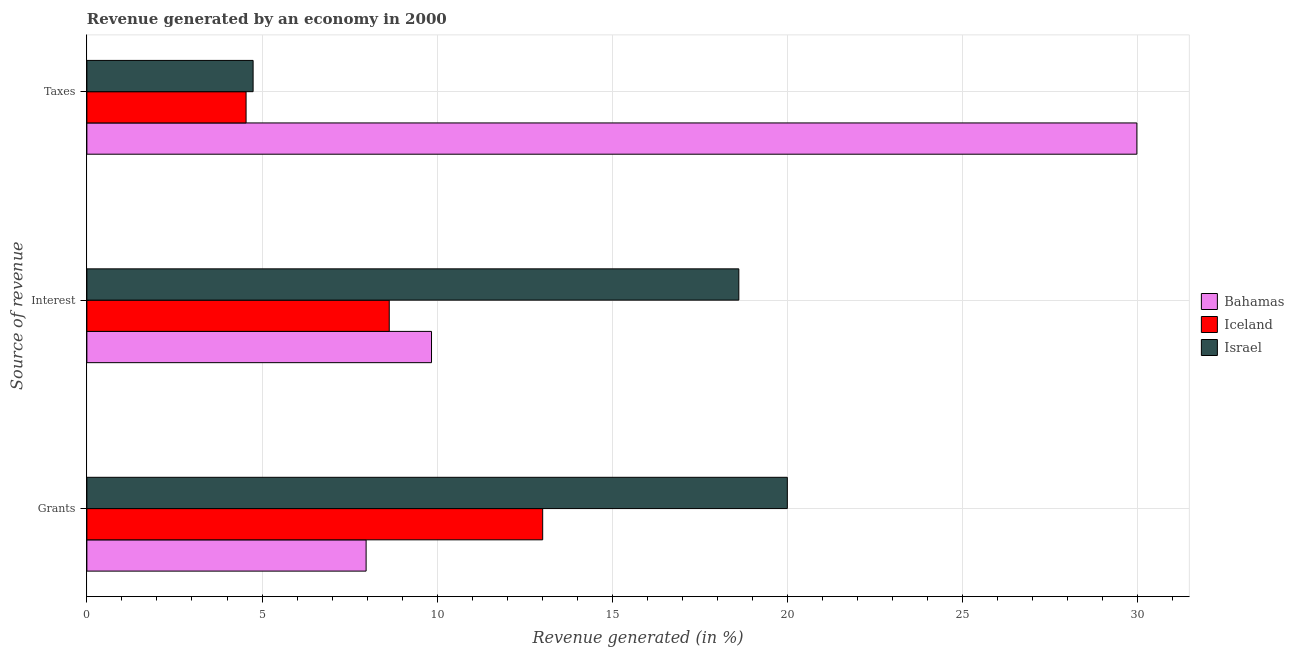How many different coloured bars are there?
Give a very brief answer. 3. How many groups of bars are there?
Make the answer very short. 3. Are the number of bars per tick equal to the number of legend labels?
Your response must be concise. Yes. Are the number of bars on each tick of the Y-axis equal?
Keep it short and to the point. Yes. What is the label of the 2nd group of bars from the top?
Keep it short and to the point. Interest. What is the percentage of revenue generated by interest in Bahamas?
Your answer should be compact. 9.84. Across all countries, what is the maximum percentage of revenue generated by grants?
Keep it short and to the point. 20. Across all countries, what is the minimum percentage of revenue generated by grants?
Give a very brief answer. 7.97. In which country was the percentage of revenue generated by grants minimum?
Make the answer very short. Bahamas. What is the total percentage of revenue generated by interest in the graph?
Offer a terse response. 37.08. What is the difference between the percentage of revenue generated by grants in Bahamas and that in Iceland?
Your answer should be compact. -5.04. What is the difference between the percentage of revenue generated by grants in Bahamas and the percentage of revenue generated by taxes in Israel?
Your response must be concise. 3.23. What is the average percentage of revenue generated by taxes per country?
Keep it short and to the point. 13.09. What is the difference between the percentage of revenue generated by grants and percentage of revenue generated by interest in Bahamas?
Your answer should be very brief. -1.87. What is the ratio of the percentage of revenue generated by interest in Israel to that in Bahamas?
Your answer should be very brief. 1.89. What is the difference between the highest and the second highest percentage of revenue generated by grants?
Make the answer very short. 6.98. What is the difference between the highest and the lowest percentage of revenue generated by taxes?
Ensure brevity in your answer.  25.43. In how many countries, is the percentage of revenue generated by grants greater than the average percentage of revenue generated by grants taken over all countries?
Ensure brevity in your answer.  1. What does the 3rd bar from the bottom in Interest represents?
Keep it short and to the point. Israel. Are the values on the major ticks of X-axis written in scientific E-notation?
Ensure brevity in your answer.  No. Does the graph contain grids?
Your answer should be very brief. Yes. Where does the legend appear in the graph?
Your answer should be compact. Center right. How many legend labels are there?
Offer a terse response. 3. What is the title of the graph?
Offer a very short reply. Revenue generated by an economy in 2000. Does "Marshall Islands" appear as one of the legend labels in the graph?
Give a very brief answer. No. What is the label or title of the X-axis?
Provide a short and direct response. Revenue generated (in %). What is the label or title of the Y-axis?
Ensure brevity in your answer.  Source of revenue. What is the Revenue generated (in %) in Bahamas in Grants?
Provide a succinct answer. 7.97. What is the Revenue generated (in %) in Iceland in Grants?
Give a very brief answer. 13.01. What is the Revenue generated (in %) in Israel in Grants?
Make the answer very short. 20. What is the Revenue generated (in %) in Bahamas in Interest?
Make the answer very short. 9.84. What is the Revenue generated (in %) in Iceland in Interest?
Give a very brief answer. 8.63. What is the Revenue generated (in %) in Israel in Interest?
Provide a succinct answer. 18.61. What is the Revenue generated (in %) in Bahamas in Taxes?
Your answer should be very brief. 29.97. What is the Revenue generated (in %) in Iceland in Taxes?
Your response must be concise. 4.54. What is the Revenue generated (in %) of Israel in Taxes?
Offer a terse response. 4.75. Across all Source of revenue, what is the maximum Revenue generated (in %) in Bahamas?
Keep it short and to the point. 29.97. Across all Source of revenue, what is the maximum Revenue generated (in %) of Iceland?
Your response must be concise. 13.01. Across all Source of revenue, what is the maximum Revenue generated (in %) of Israel?
Provide a succinct answer. 20. Across all Source of revenue, what is the minimum Revenue generated (in %) of Bahamas?
Your response must be concise. 7.97. Across all Source of revenue, what is the minimum Revenue generated (in %) in Iceland?
Your answer should be compact. 4.54. Across all Source of revenue, what is the minimum Revenue generated (in %) in Israel?
Give a very brief answer. 4.75. What is the total Revenue generated (in %) of Bahamas in the graph?
Give a very brief answer. 47.78. What is the total Revenue generated (in %) of Iceland in the graph?
Provide a succinct answer. 26.19. What is the total Revenue generated (in %) in Israel in the graph?
Your answer should be very brief. 43.35. What is the difference between the Revenue generated (in %) of Bahamas in Grants and that in Interest?
Provide a succinct answer. -1.87. What is the difference between the Revenue generated (in %) of Iceland in Grants and that in Interest?
Your answer should be very brief. 4.38. What is the difference between the Revenue generated (in %) of Israel in Grants and that in Interest?
Your response must be concise. 1.38. What is the difference between the Revenue generated (in %) in Bahamas in Grants and that in Taxes?
Offer a very short reply. -22. What is the difference between the Revenue generated (in %) of Iceland in Grants and that in Taxes?
Ensure brevity in your answer.  8.47. What is the difference between the Revenue generated (in %) of Israel in Grants and that in Taxes?
Give a very brief answer. 15.25. What is the difference between the Revenue generated (in %) of Bahamas in Interest and that in Taxes?
Offer a very short reply. -20.14. What is the difference between the Revenue generated (in %) in Iceland in Interest and that in Taxes?
Your answer should be compact. 4.09. What is the difference between the Revenue generated (in %) in Israel in Interest and that in Taxes?
Provide a succinct answer. 13.87. What is the difference between the Revenue generated (in %) in Bahamas in Grants and the Revenue generated (in %) in Iceland in Interest?
Offer a very short reply. -0.66. What is the difference between the Revenue generated (in %) of Bahamas in Grants and the Revenue generated (in %) of Israel in Interest?
Your response must be concise. -10.64. What is the difference between the Revenue generated (in %) of Iceland in Grants and the Revenue generated (in %) of Israel in Interest?
Ensure brevity in your answer.  -5.6. What is the difference between the Revenue generated (in %) of Bahamas in Grants and the Revenue generated (in %) of Iceland in Taxes?
Your answer should be compact. 3.43. What is the difference between the Revenue generated (in %) of Bahamas in Grants and the Revenue generated (in %) of Israel in Taxes?
Offer a terse response. 3.23. What is the difference between the Revenue generated (in %) in Iceland in Grants and the Revenue generated (in %) in Israel in Taxes?
Keep it short and to the point. 8.27. What is the difference between the Revenue generated (in %) of Bahamas in Interest and the Revenue generated (in %) of Iceland in Taxes?
Make the answer very short. 5.29. What is the difference between the Revenue generated (in %) of Bahamas in Interest and the Revenue generated (in %) of Israel in Taxes?
Ensure brevity in your answer.  5.09. What is the difference between the Revenue generated (in %) in Iceland in Interest and the Revenue generated (in %) in Israel in Taxes?
Your response must be concise. 3.89. What is the average Revenue generated (in %) of Bahamas per Source of revenue?
Ensure brevity in your answer.  15.93. What is the average Revenue generated (in %) in Iceland per Source of revenue?
Your answer should be compact. 8.73. What is the average Revenue generated (in %) in Israel per Source of revenue?
Ensure brevity in your answer.  14.45. What is the difference between the Revenue generated (in %) in Bahamas and Revenue generated (in %) in Iceland in Grants?
Provide a short and direct response. -5.04. What is the difference between the Revenue generated (in %) of Bahamas and Revenue generated (in %) of Israel in Grants?
Your answer should be compact. -12.02. What is the difference between the Revenue generated (in %) in Iceland and Revenue generated (in %) in Israel in Grants?
Your answer should be compact. -6.98. What is the difference between the Revenue generated (in %) in Bahamas and Revenue generated (in %) in Iceland in Interest?
Give a very brief answer. 1.21. What is the difference between the Revenue generated (in %) in Bahamas and Revenue generated (in %) in Israel in Interest?
Your response must be concise. -8.77. What is the difference between the Revenue generated (in %) in Iceland and Revenue generated (in %) in Israel in Interest?
Give a very brief answer. -9.98. What is the difference between the Revenue generated (in %) in Bahamas and Revenue generated (in %) in Iceland in Taxes?
Give a very brief answer. 25.43. What is the difference between the Revenue generated (in %) of Bahamas and Revenue generated (in %) of Israel in Taxes?
Give a very brief answer. 25.23. What is the difference between the Revenue generated (in %) in Iceland and Revenue generated (in %) in Israel in Taxes?
Ensure brevity in your answer.  -0.2. What is the ratio of the Revenue generated (in %) of Bahamas in Grants to that in Interest?
Provide a succinct answer. 0.81. What is the ratio of the Revenue generated (in %) in Iceland in Grants to that in Interest?
Keep it short and to the point. 1.51. What is the ratio of the Revenue generated (in %) in Israel in Grants to that in Interest?
Provide a short and direct response. 1.07. What is the ratio of the Revenue generated (in %) of Bahamas in Grants to that in Taxes?
Your answer should be compact. 0.27. What is the ratio of the Revenue generated (in %) in Iceland in Grants to that in Taxes?
Offer a terse response. 2.86. What is the ratio of the Revenue generated (in %) of Israel in Grants to that in Taxes?
Provide a short and direct response. 4.21. What is the ratio of the Revenue generated (in %) in Bahamas in Interest to that in Taxes?
Provide a short and direct response. 0.33. What is the ratio of the Revenue generated (in %) in Iceland in Interest to that in Taxes?
Your answer should be compact. 1.9. What is the ratio of the Revenue generated (in %) in Israel in Interest to that in Taxes?
Keep it short and to the point. 3.92. What is the difference between the highest and the second highest Revenue generated (in %) in Bahamas?
Give a very brief answer. 20.14. What is the difference between the highest and the second highest Revenue generated (in %) in Iceland?
Make the answer very short. 4.38. What is the difference between the highest and the second highest Revenue generated (in %) in Israel?
Your answer should be compact. 1.38. What is the difference between the highest and the lowest Revenue generated (in %) in Bahamas?
Your answer should be very brief. 22. What is the difference between the highest and the lowest Revenue generated (in %) in Iceland?
Your answer should be very brief. 8.47. What is the difference between the highest and the lowest Revenue generated (in %) of Israel?
Keep it short and to the point. 15.25. 